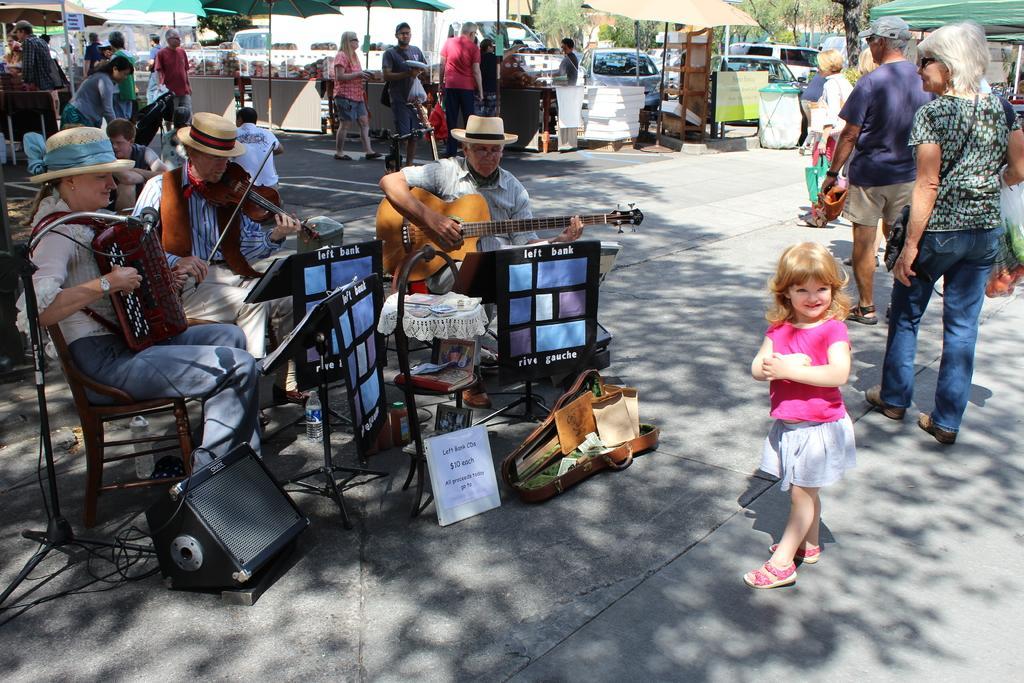How would you summarize this image in a sentence or two? This is the picture taken in the outdoors, there are three persons sitting on a chair and playing music instruments. Behind the people there are group of people standing and a stall. 